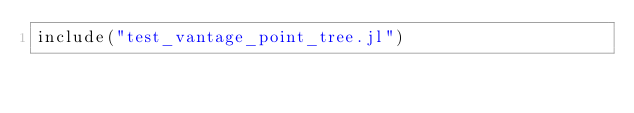<code> <loc_0><loc_0><loc_500><loc_500><_Julia_>include("test_vantage_point_tree.jl")</code> 